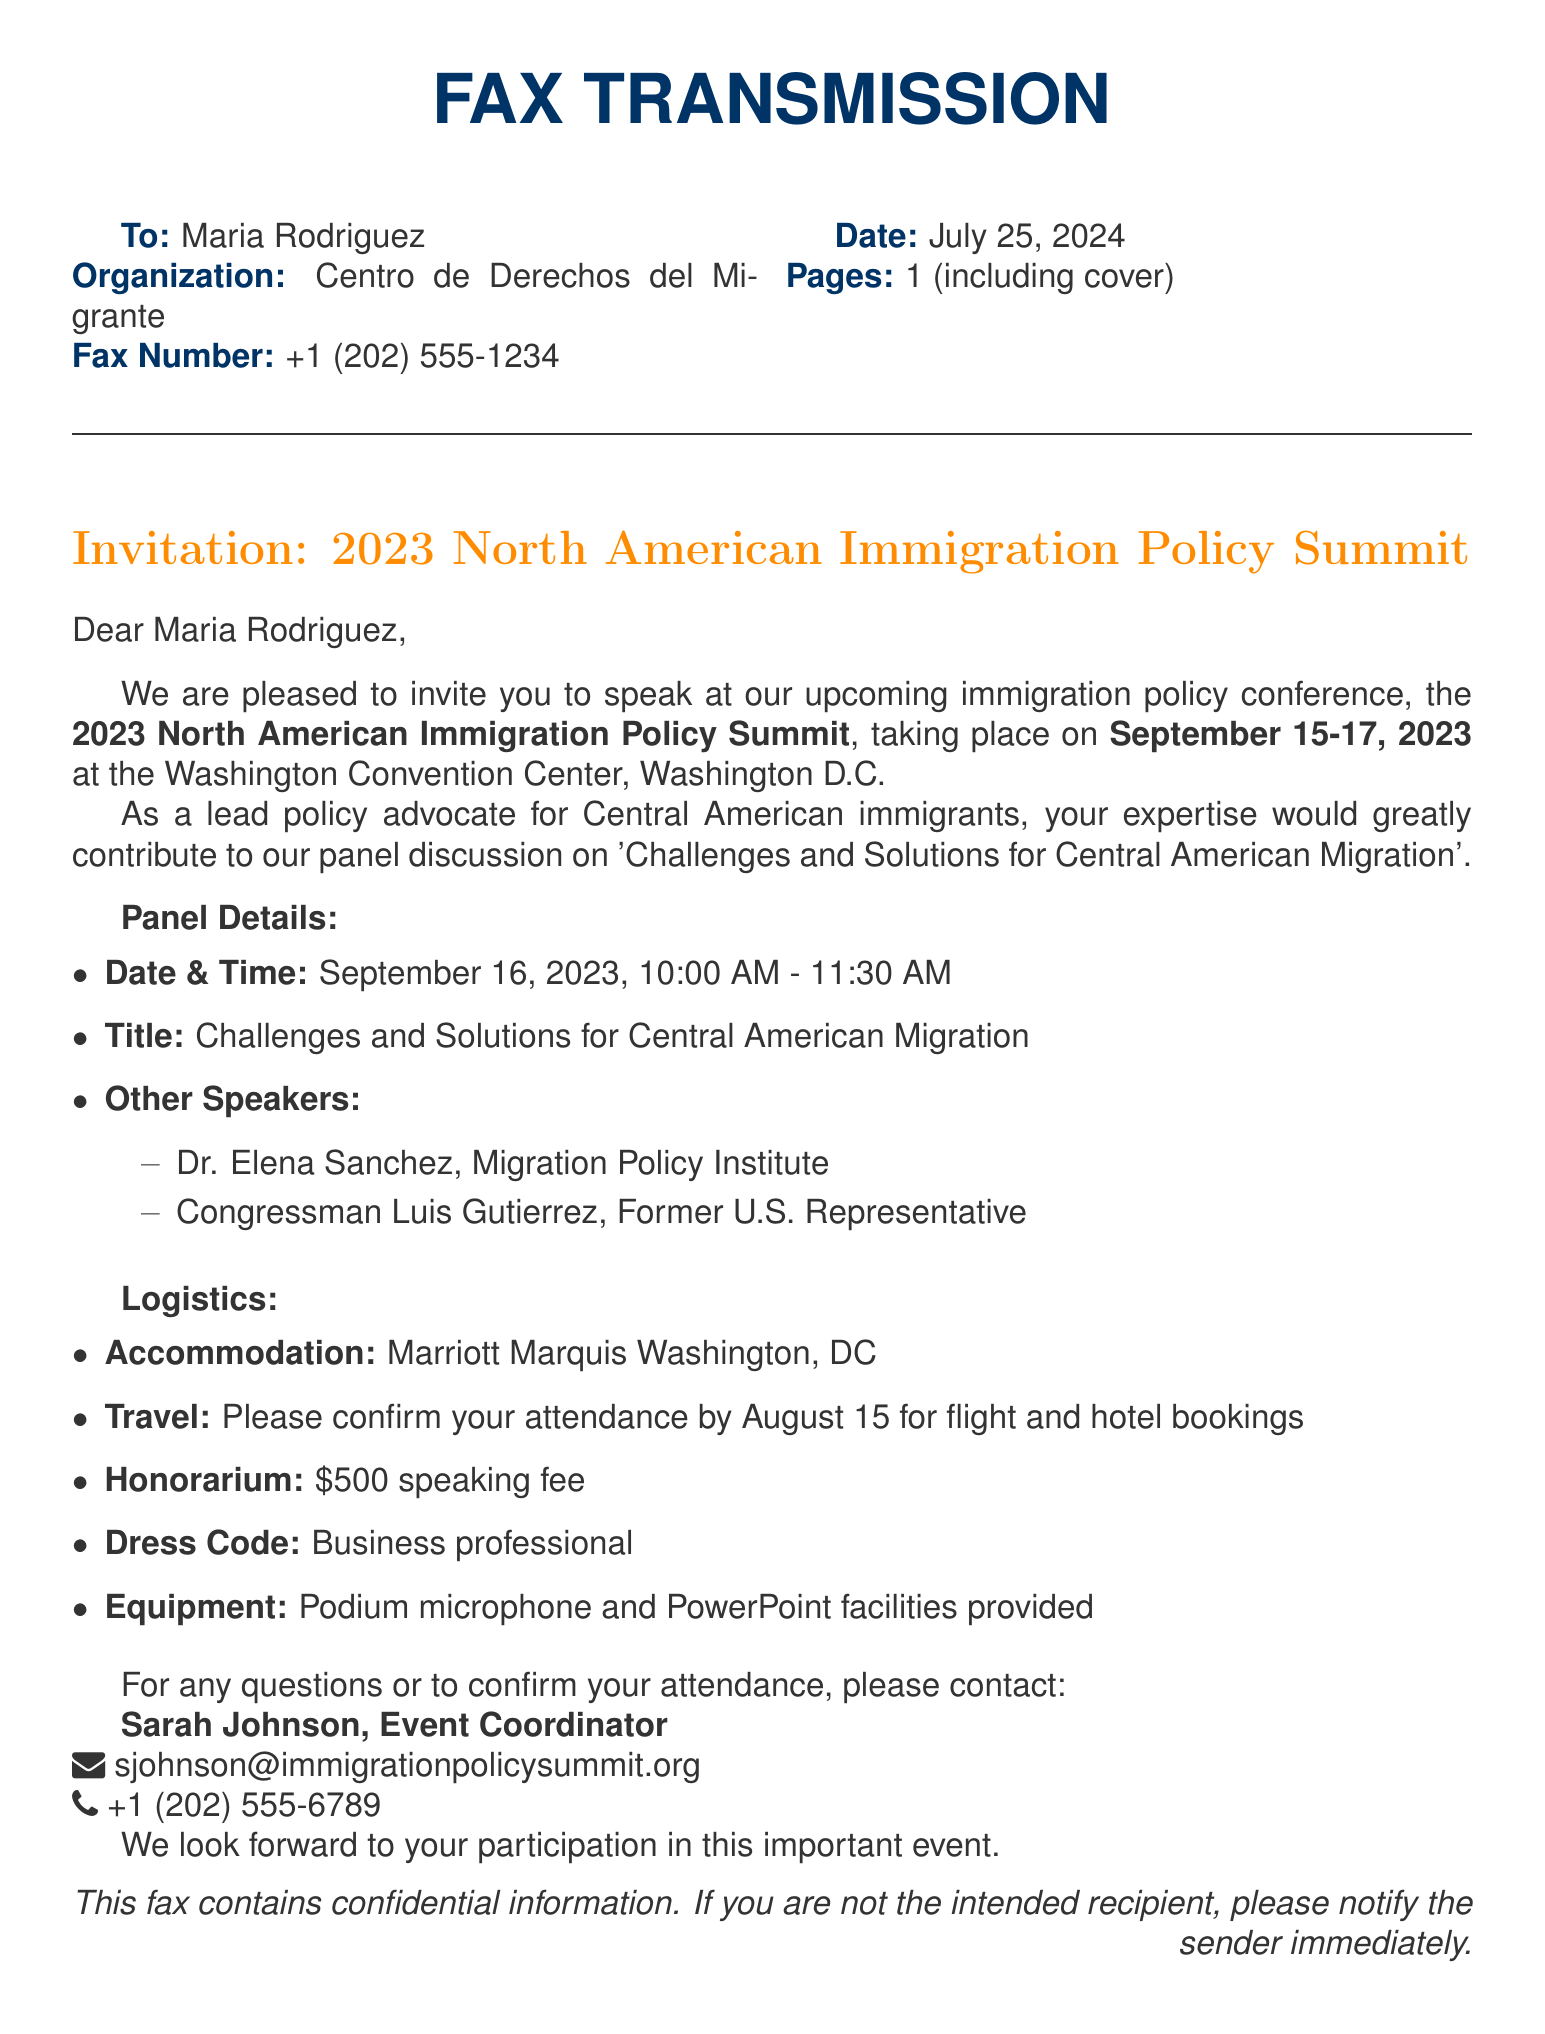What is the event title? The event title is mentioned in the introduction section of the document as the main focus of the invitation.
Answer: 2023 North American Immigration Policy Summit Who is the invitation addressed to? The document specifies the recipient of the fax under the "To:" section, indicating the intended recipient of the invitation.
Answer: Maria Rodriguez What are the dates of the conference? The dates of the conference are provided in the introduction, highlighting when the event will take place.
Answer: September 15-17, 2023 What is the honorarium amount for speaking? The document lists the speaking fee as part of the logistical information related to the event.
Answer: $500 What is the dress code for the event? The dress code is explicitly mentioned under the logistics section of the fax, indicating the required attire for the participants.
Answer: Business professional What time does the panel discussion start? The document contains specific timing for the panel discussion, providing clarity on when the event segment will begin.
Answer: 10:00 AM Who will be a speaker alongside Maria Rodriguez? The document provides names of other speakers in the panel discussion section, indicating who else will participate.
Answer: Dr. Elena Sanchez When should attendance be confirmed? The deadline for confirmation is stated in the logistics section, providing a timeline for attendees.
Answer: August 15 